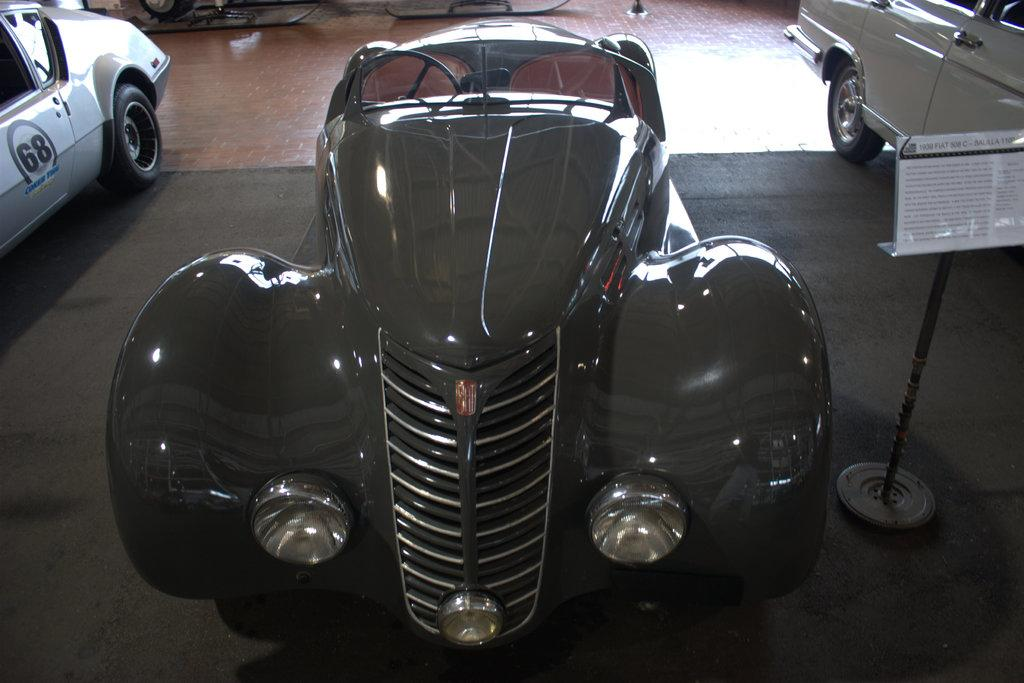What objects are on the floor in the image? There are vehicles on the floor in the image. Can you describe the vehicles? The vehicles are not described in the provided facts, so we cannot provide further details about them. How many vehicles are on the floor? The number of vehicles is not specified in the provided facts, so we cannot determine the exact number. What advice does the lawyer give to the grandfather in the image? There is no lawyer or grandfather present in the image, so this question cannot be answered based on the provided facts. 